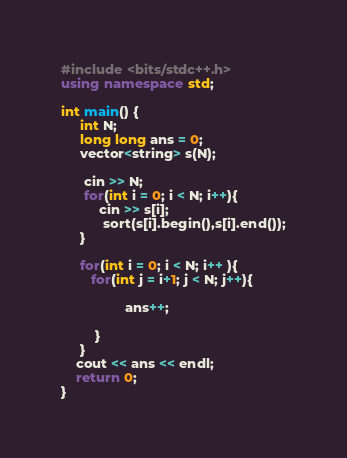<code> <loc_0><loc_0><loc_500><loc_500><_C++_>#include <bits/stdc++.h>
using namespace std;
 
int main() {   
     int N;
     long long ans = 0;
     vector<string> s(N);
 
      cin >> N;
      for(int i = 0; i < N; i++){
          cin >> s[i];
           sort(s[i].begin(),s[i].end());
     }
    
     for(int i = 0; i < N; i++ ){
        for(int j = i+1; j < N; j++){
        
                 ans++;
  
         }
     }
    cout << ans << endl;
    return 0;
}</code> 